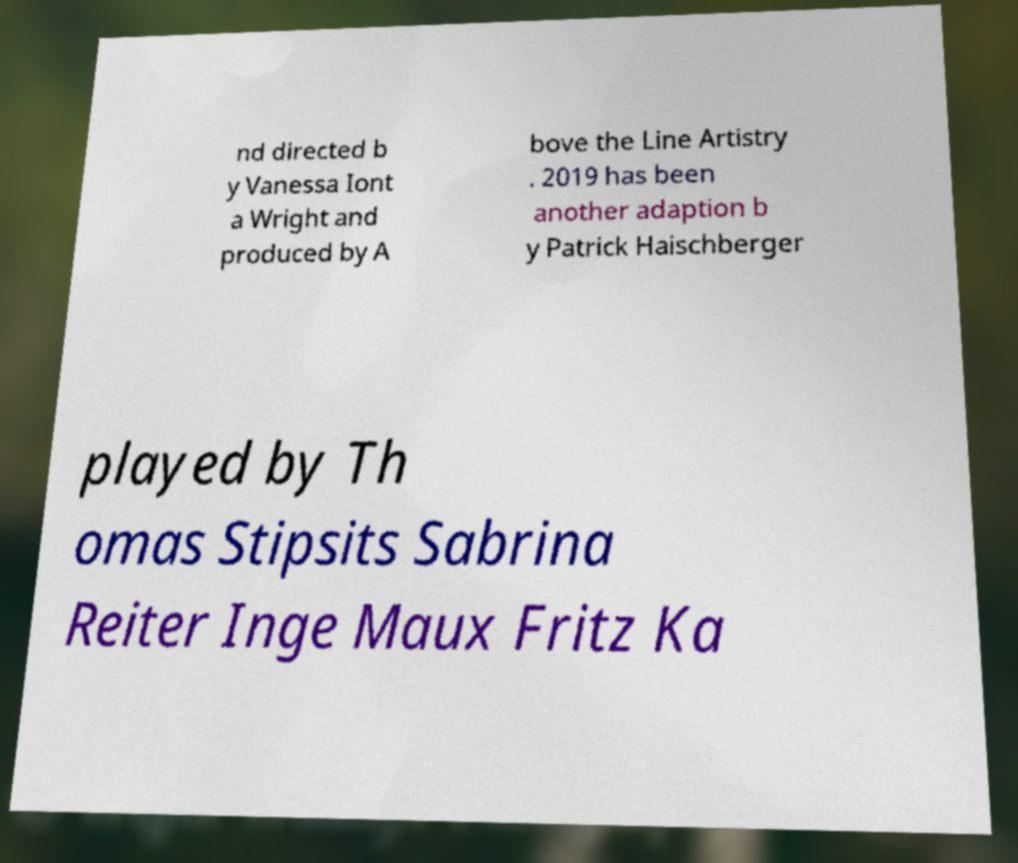Can you accurately transcribe the text from the provided image for me? nd directed b y Vanessa Iont a Wright and produced by A bove the Line Artistry . 2019 has been another adaption b y Patrick Haischberger played by Th omas Stipsits Sabrina Reiter Inge Maux Fritz Ka 